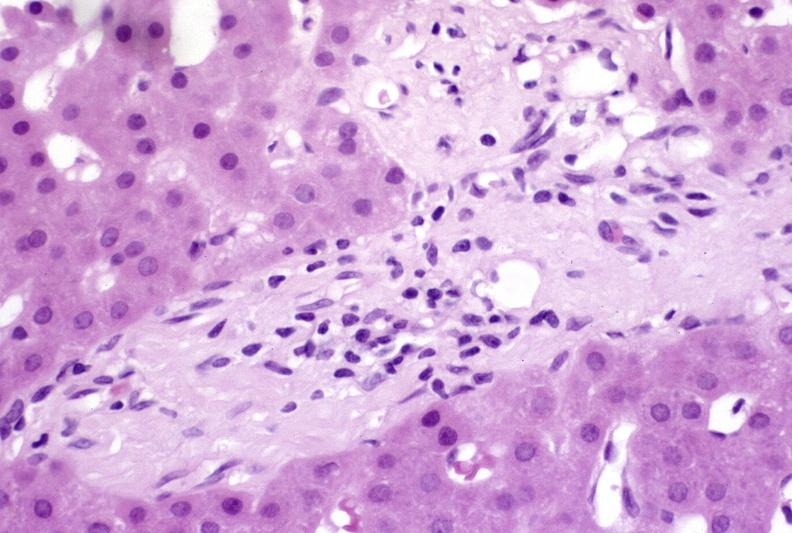what is present?
Answer the question using a single word or phrase. Hepatobiliary 